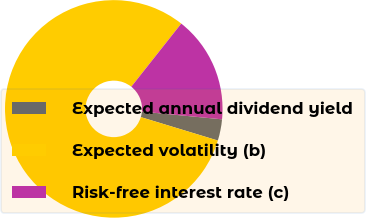Convert chart to OTSL. <chart><loc_0><loc_0><loc_500><loc_500><pie_chart><fcel>Expected annual dividend yield<fcel>Expected volatility (b)<fcel>Risk-free interest rate (c)<nl><fcel>3.17%<fcel>80.95%<fcel>15.88%<nl></chart> 